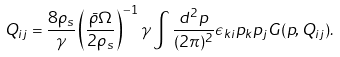<formula> <loc_0><loc_0><loc_500><loc_500>Q _ { i j } = \frac { 8 \rho _ { s } } { \gamma } \left ( \frac { \bar { \rho } \Omega } { 2 \rho _ { s } } \right ) ^ { - 1 } \gamma \int \frac { d ^ { 2 } p } { ( 2 \pi ) ^ { 2 } } \epsilon _ { k i } p _ { k } p _ { j } G ( { p } , Q _ { i j } ) .</formula> 